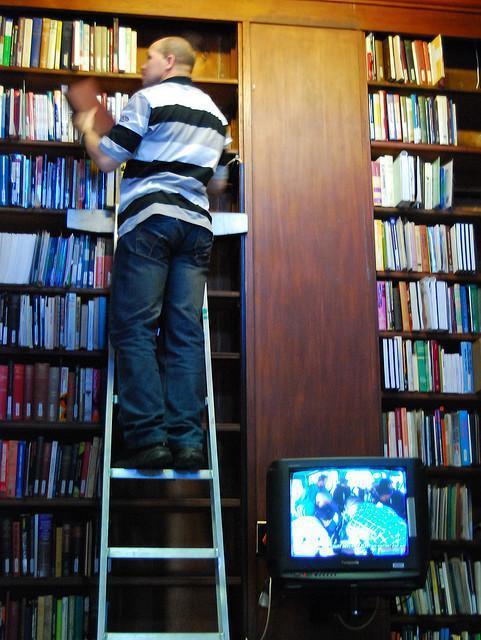How many donuts are read with black face?
Give a very brief answer. 0. 